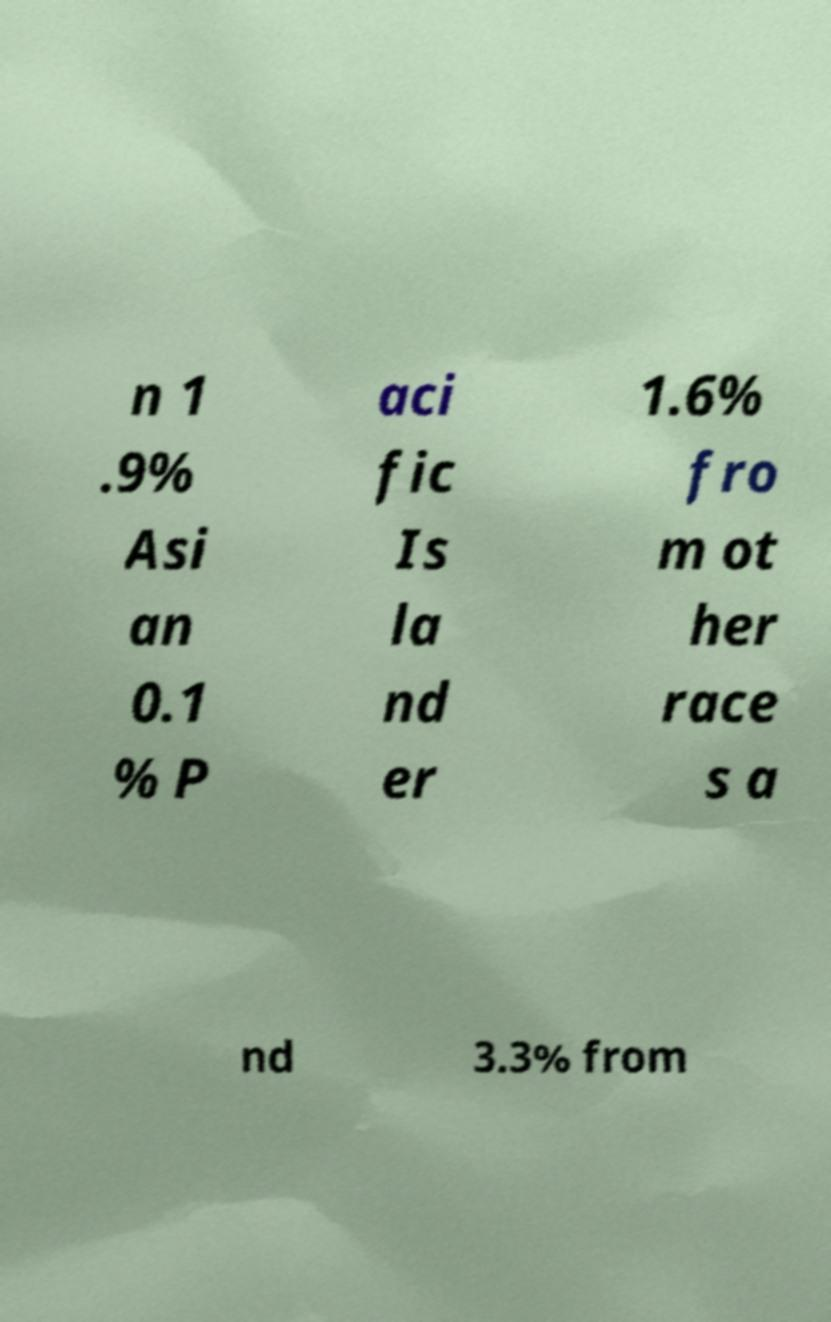There's text embedded in this image that I need extracted. Can you transcribe it verbatim? n 1 .9% Asi an 0.1 % P aci fic Is la nd er 1.6% fro m ot her race s a nd 3.3% from 